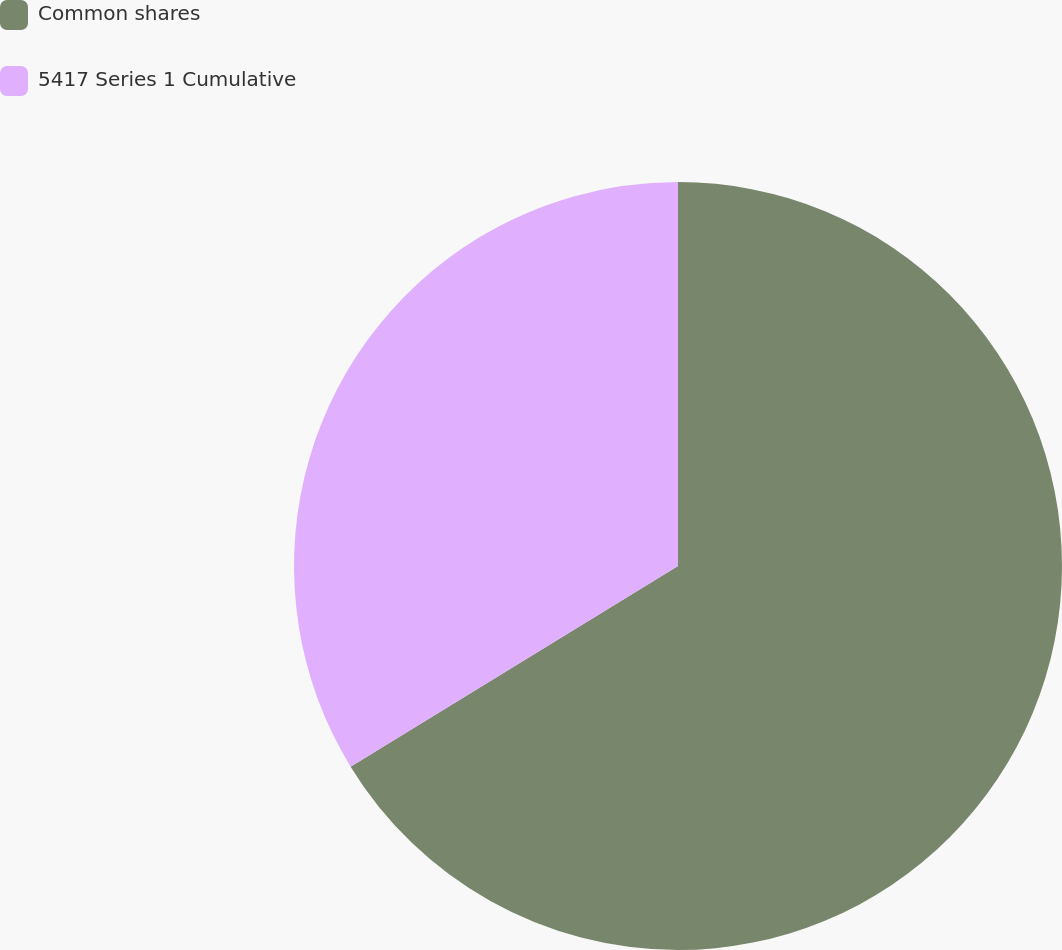<chart> <loc_0><loc_0><loc_500><loc_500><pie_chart><fcel>Common shares<fcel>5417 Series 1 Cumulative<nl><fcel>66.25%<fcel>33.75%<nl></chart> 